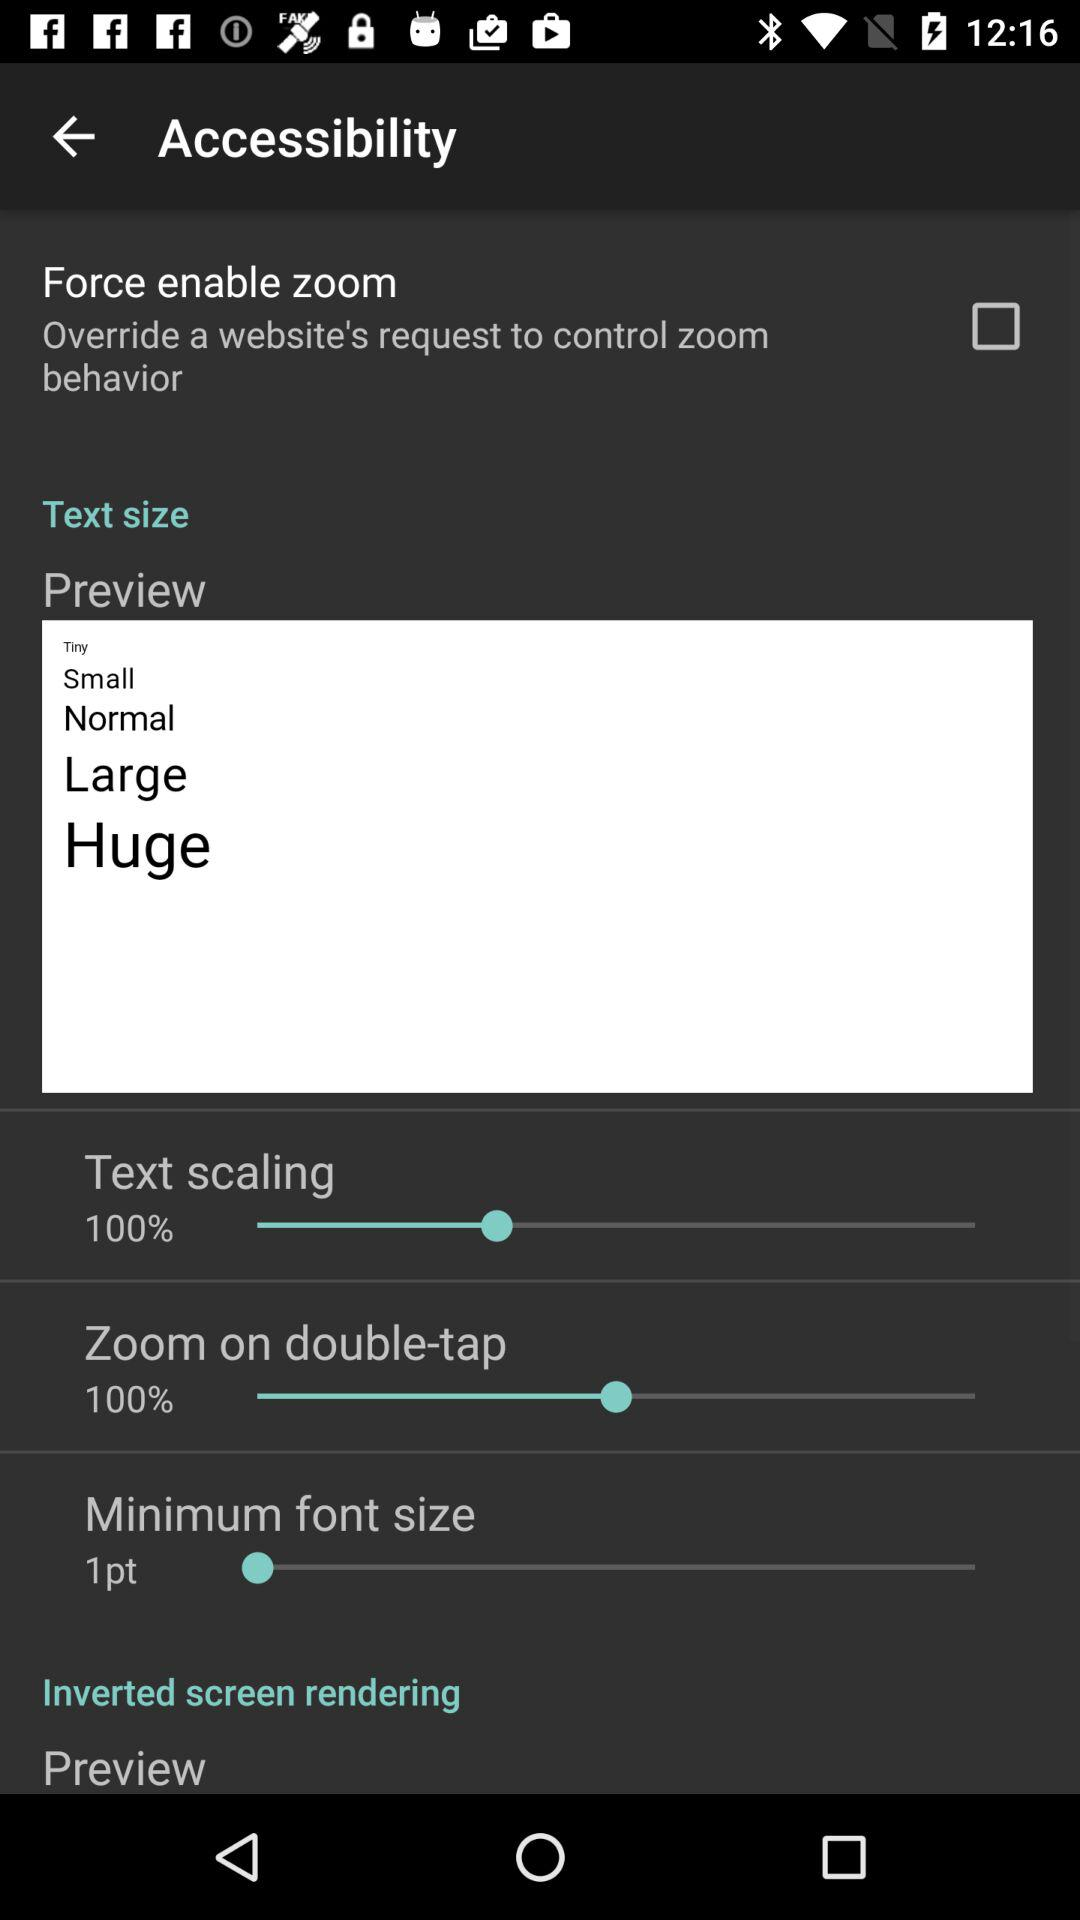What is the minimum font size? The minimum font size is 1 pt. 